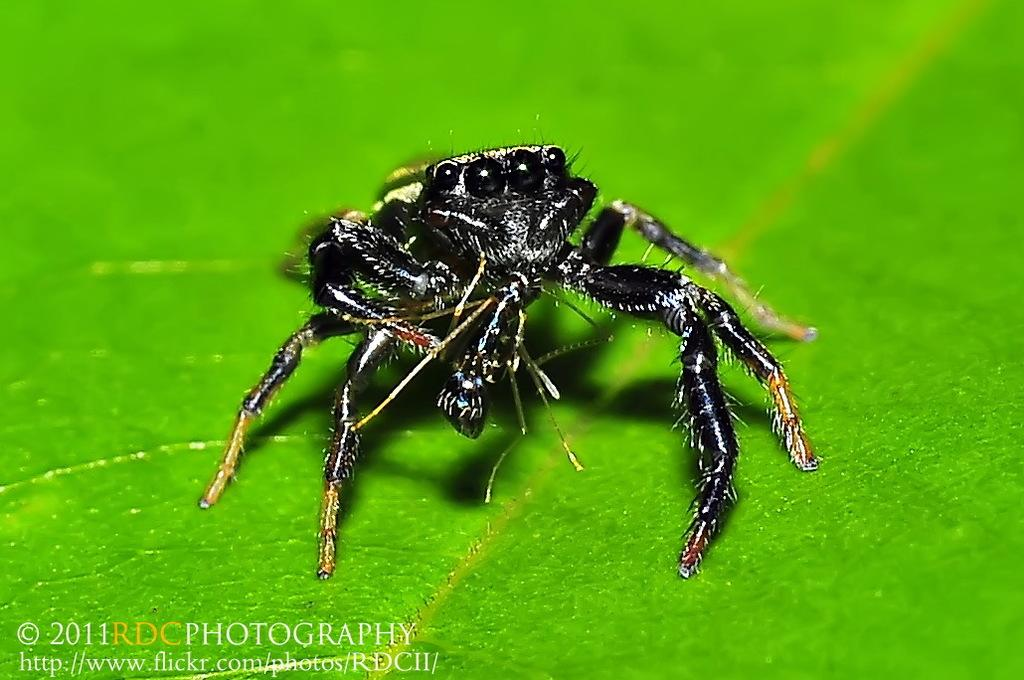What is present on the leaf in the image? There is an insect on a leaf in the image. What can be found in the bottom left corner of the image? There is text in the bottom left corner of the image. How many birds are in the flock flying over the insect in the image? There is no flock of birds present in the image; it only features an insect on a leaf. 